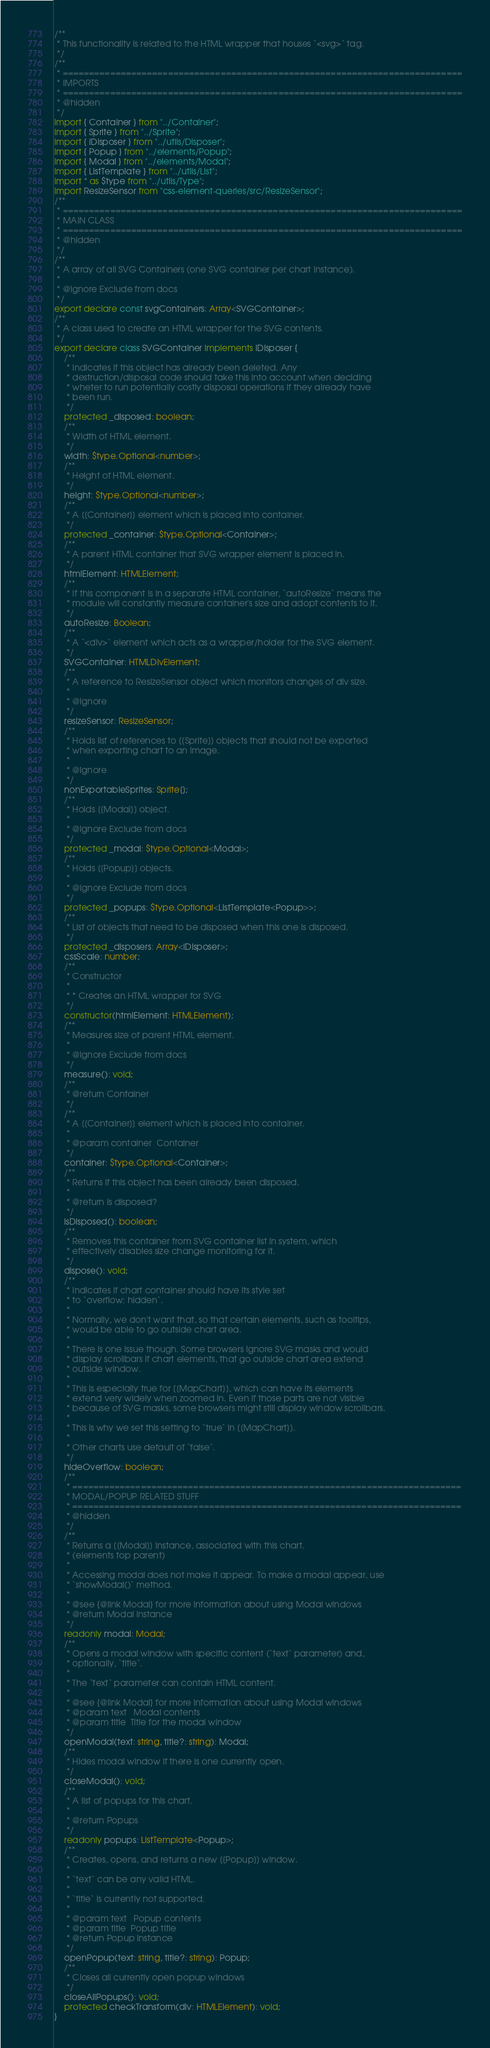Convert code to text. <code><loc_0><loc_0><loc_500><loc_500><_TypeScript_>/**
 * This functionality is related to the HTML wrapper that houses `<svg>` tag.
 */
/**
 * ============================================================================
 * IMPORTS
 * ============================================================================
 * @hidden
 */
import { Container } from "../Container";
import { Sprite } from "../Sprite";
import { IDisposer } from "../utils/Disposer";
import { Popup } from "../elements/Popup";
import { Modal } from "../elements/Modal";
import { ListTemplate } from "../utils/List";
import * as $type from "../utils/Type";
import ResizeSensor from "css-element-queries/src/ResizeSensor";
/**
 * ============================================================================
 * MAIN CLASS
 * ============================================================================
 * @hidden
 */
/**
 * A array of all SVG Containers (one SVG container per chart instance).
 *
 * @ignore Exclude from docs
 */
export declare const svgContainers: Array<SVGContainer>;
/**
 * A class used to create an HTML wrapper for the SVG contents.
 */
export declare class SVGContainer implements IDisposer {
    /**
     * Indicates if this object has already been deleted. Any
     * destruction/disposal code should take this into account when deciding
     * wheter to run potentially costly disposal operations if they already have
     * been run.
     */
    protected _disposed: boolean;
    /**
     * Width of HTML element.
     */
    width: $type.Optional<number>;
    /**
     * Height of HTML element.
     */
    height: $type.Optional<number>;
    /**
     * A [[Container]] element which is placed into container.
     */
    protected _container: $type.Optional<Container>;
    /**
     * A parent HTML container that SVG wrapper element is placed in.
     */
    htmlElement: HTMLElement;
    /**
     * If this component is in a separate HTML container, `autoResize` means the
     * module will constantly measure container's size and adopt contents to it.
     */
    autoResize: Boolean;
    /**
     * A `<div>` element which acts as a wrapper/holder for the SVG element.
     */
    SVGContainer: HTMLDivElement;
    /**
     * A reference to ResizeSensor object which monitors changes of div size.
     *
     * @ignore
     */
    resizeSensor: ResizeSensor;
    /**
     * Holds list of references to [[Sprite]] objects that should not be exported
     * when exporting chart to an image.
     *
     * @ignore
     */
    nonExportableSprites: Sprite[];
    /**
     * Holds [[Modal]] object.
     *
     * @ignore Exclude from docs
     */
    protected _modal: $type.Optional<Modal>;
    /**
     * Holds [[Popup]] objects.
     *
     * @ignore Exclude from docs
     */
    protected _popups: $type.Optional<ListTemplate<Popup>>;
    /**
     * List of objects that need to be disposed when this one is disposed.
     */
    protected _disposers: Array<IDisposer>;
    cssScale: number;
    /**
     * Constructor
     *
     * * Creates an HTML wrapper for SVG
     */
    constructor(htmlElement: HTMLElement);
    /**
     * Measures size of parent HTML element.
     *
     * @ignore Exclude from docs
     */
    measure(): void;
    /**
     * @return Container
     */
    /**
     * A [[Container]] element which is placed into container.
     *
     * @param container  Container
     */
    container: $type.Optional<Container>;
    /**
     * Returns if this object has been already been disposed.
     *
     * @return Is disposed?
     */
    isDisposed(): boolean;
    /**
     * Removes this container from SVG container list in system, which
     * effectively disables size change monitoring for it.
     */
    dispose(): void;
    /**
     * Indicates if chart container should have its style set
     * to `overflow: hidden`.
     *
     * Normally, we don't want that, so that certain elements, such as tooltips,
     * would be able to go outside chart area.
     *
     * There is one issue though. Some browsers ignore SVG masks and would
     * display scrollbars if chart elements, that go outside chart area extend
     * outside window.
     *
     * This is especially true for [[MapChart]], which can have its elements
     * extend very widely when zoomed in. Even if those parts are not visible
     * because of SVG masks, some browsers might still display window scrollbars.
     *
     * This is why we set this setting to `true` in [[MapChart]].
     *
     * Other charts use default of `false`.
     */
    hideOverflow: boolean;
    /**
     * ==========================================================================
     * MODAL/POPUP RELATED STUFF
     * ==========================================================================
     * @hidden
     */
    /**
     * Returns a [[Modal]] instance, associated with this chart.
     * (elements top parent)
     *
     * Accessing modal does not make it appear. To make a modal appear, use
     * `showModal()` method.
     *
     * @see {@link Modal} for more information about using Modal windows
     * @return Modal instance
     */
    readonly modal: Modal;
    /**
     * Opens a modal window with specific content (`text` parameter) and,
     * optionally, `title`.
     *
     * The `text` parameter can contain HTML content.
     *
     * @see {@link Modal} for more information about using Modal windows
     * @param text   Modal contents
     * @param title  Title for the modal window
     */
    openModal(text: string, title?: string): Modal;
    /**
     * Hides modal window if there is one currently open.
     */
    closeModal(): void;
    /**
     * A list of popups for this chart.
     *
     * @return Popups
     */
    readonly popups: ListTemplate<Popup>;
    /**
     * Creates, opens, and returns a new [[Popup]] window.
     *
     * `text` can be any valid HTML.
     *
     * `title` is currently not supported.
     *
     * @param text   Popup contents
     * @param title  Popup title
     * @return Popup instance
     */
    openPopup(text: string, title?: string): Popup;
    /**
     * Closes all currently open popup windows
     */
    closeAllPopups(): void;
    protected checkTransform(div: HTMLElement): void;
}
</code> 